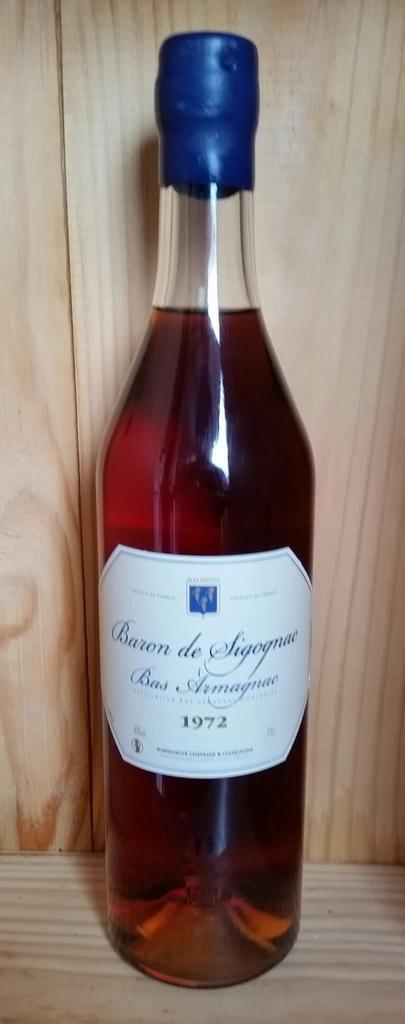Provide a one-sentence caption for the provided image. A bottle of wine from 1972 has a blue cover over the cork. 